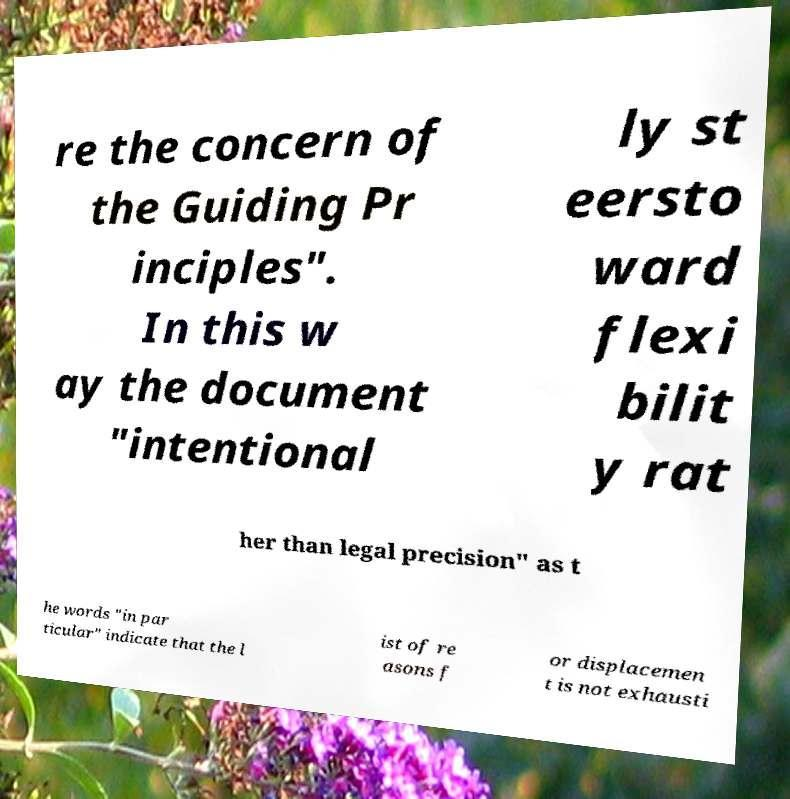Could you extract and type out the text from this image? re the concern of the Guiding Pr inciples". In this w ay the document "intentional ly st eersto ward flexi bilit y rat her than legal precision" as t he words "in par ticular" indicate that the l ist of re asons f or displacemen t is not exhausti 